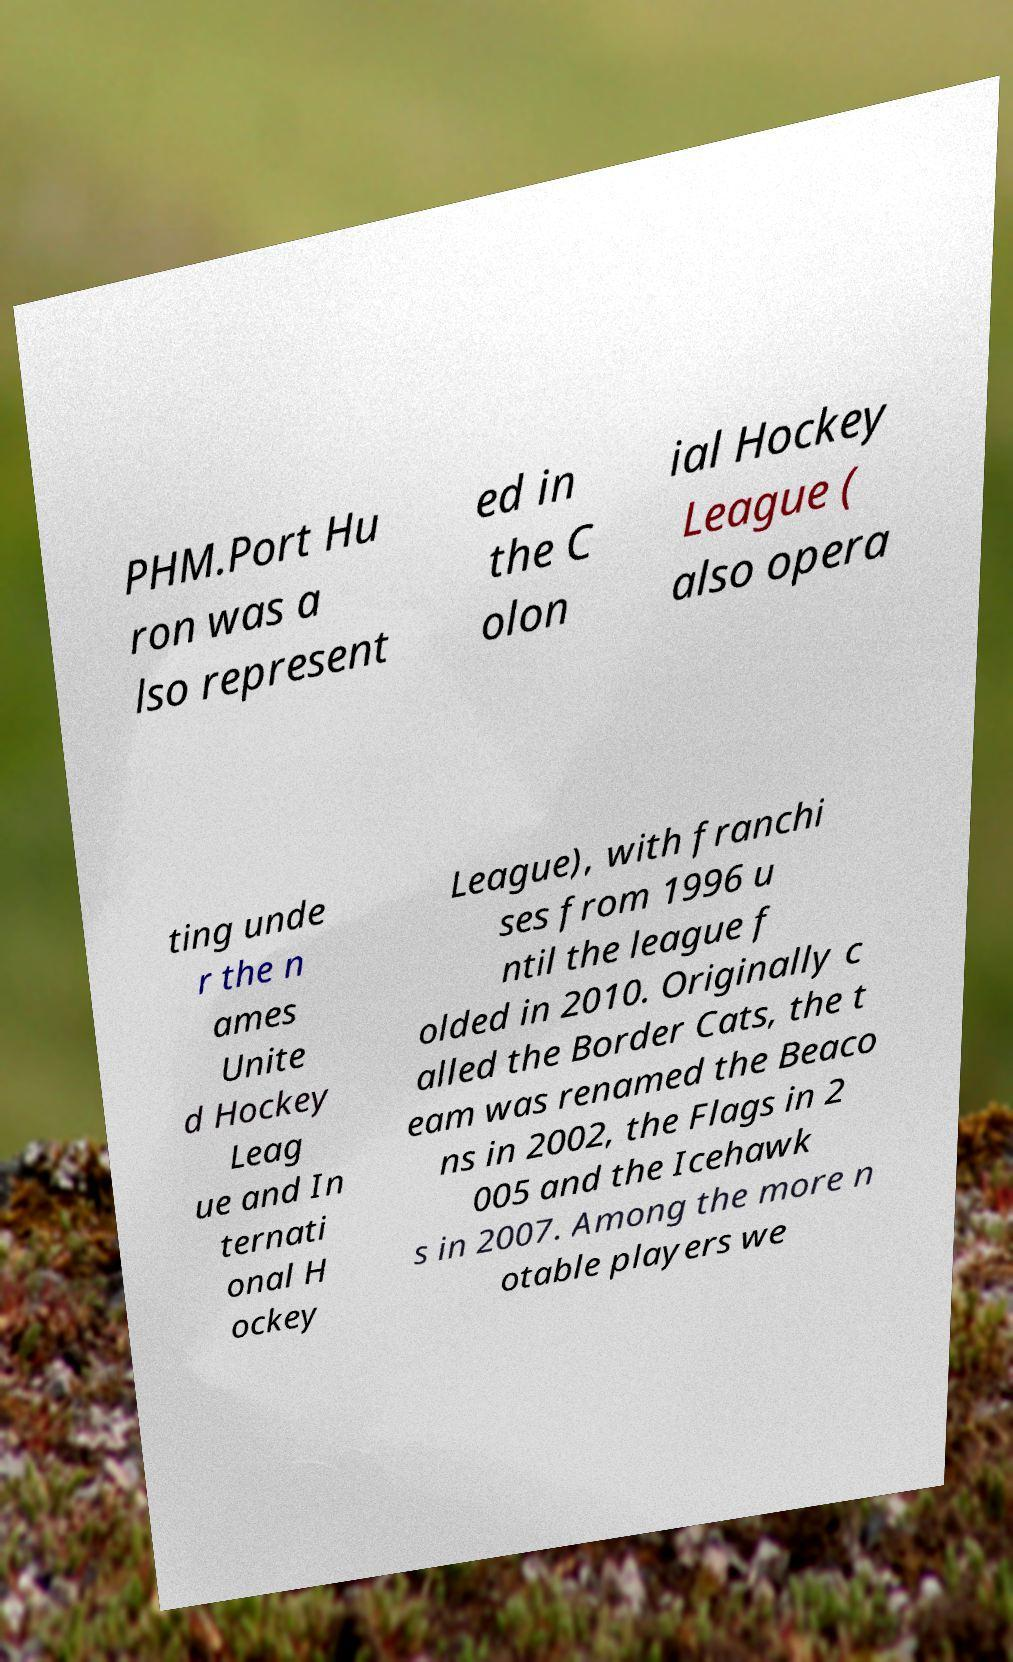What messages or text are displayed in this image? I need them in a readable, typed format. PHM.Port Hu ron was a lso represent ed in the C olon ial Hockey League ( also opera ting unde r the n ames Unite d Hockey Leag ue and In ternati onal H ockey League), with franchi ses from 1996 u ntil the league f olded in 2010. Originally c alled the Border Cats, the t eam was renamed the Beaco ns in 2002, the Flags in 2 005 and the Icehawk s in 2007. Among the more n otable players we 